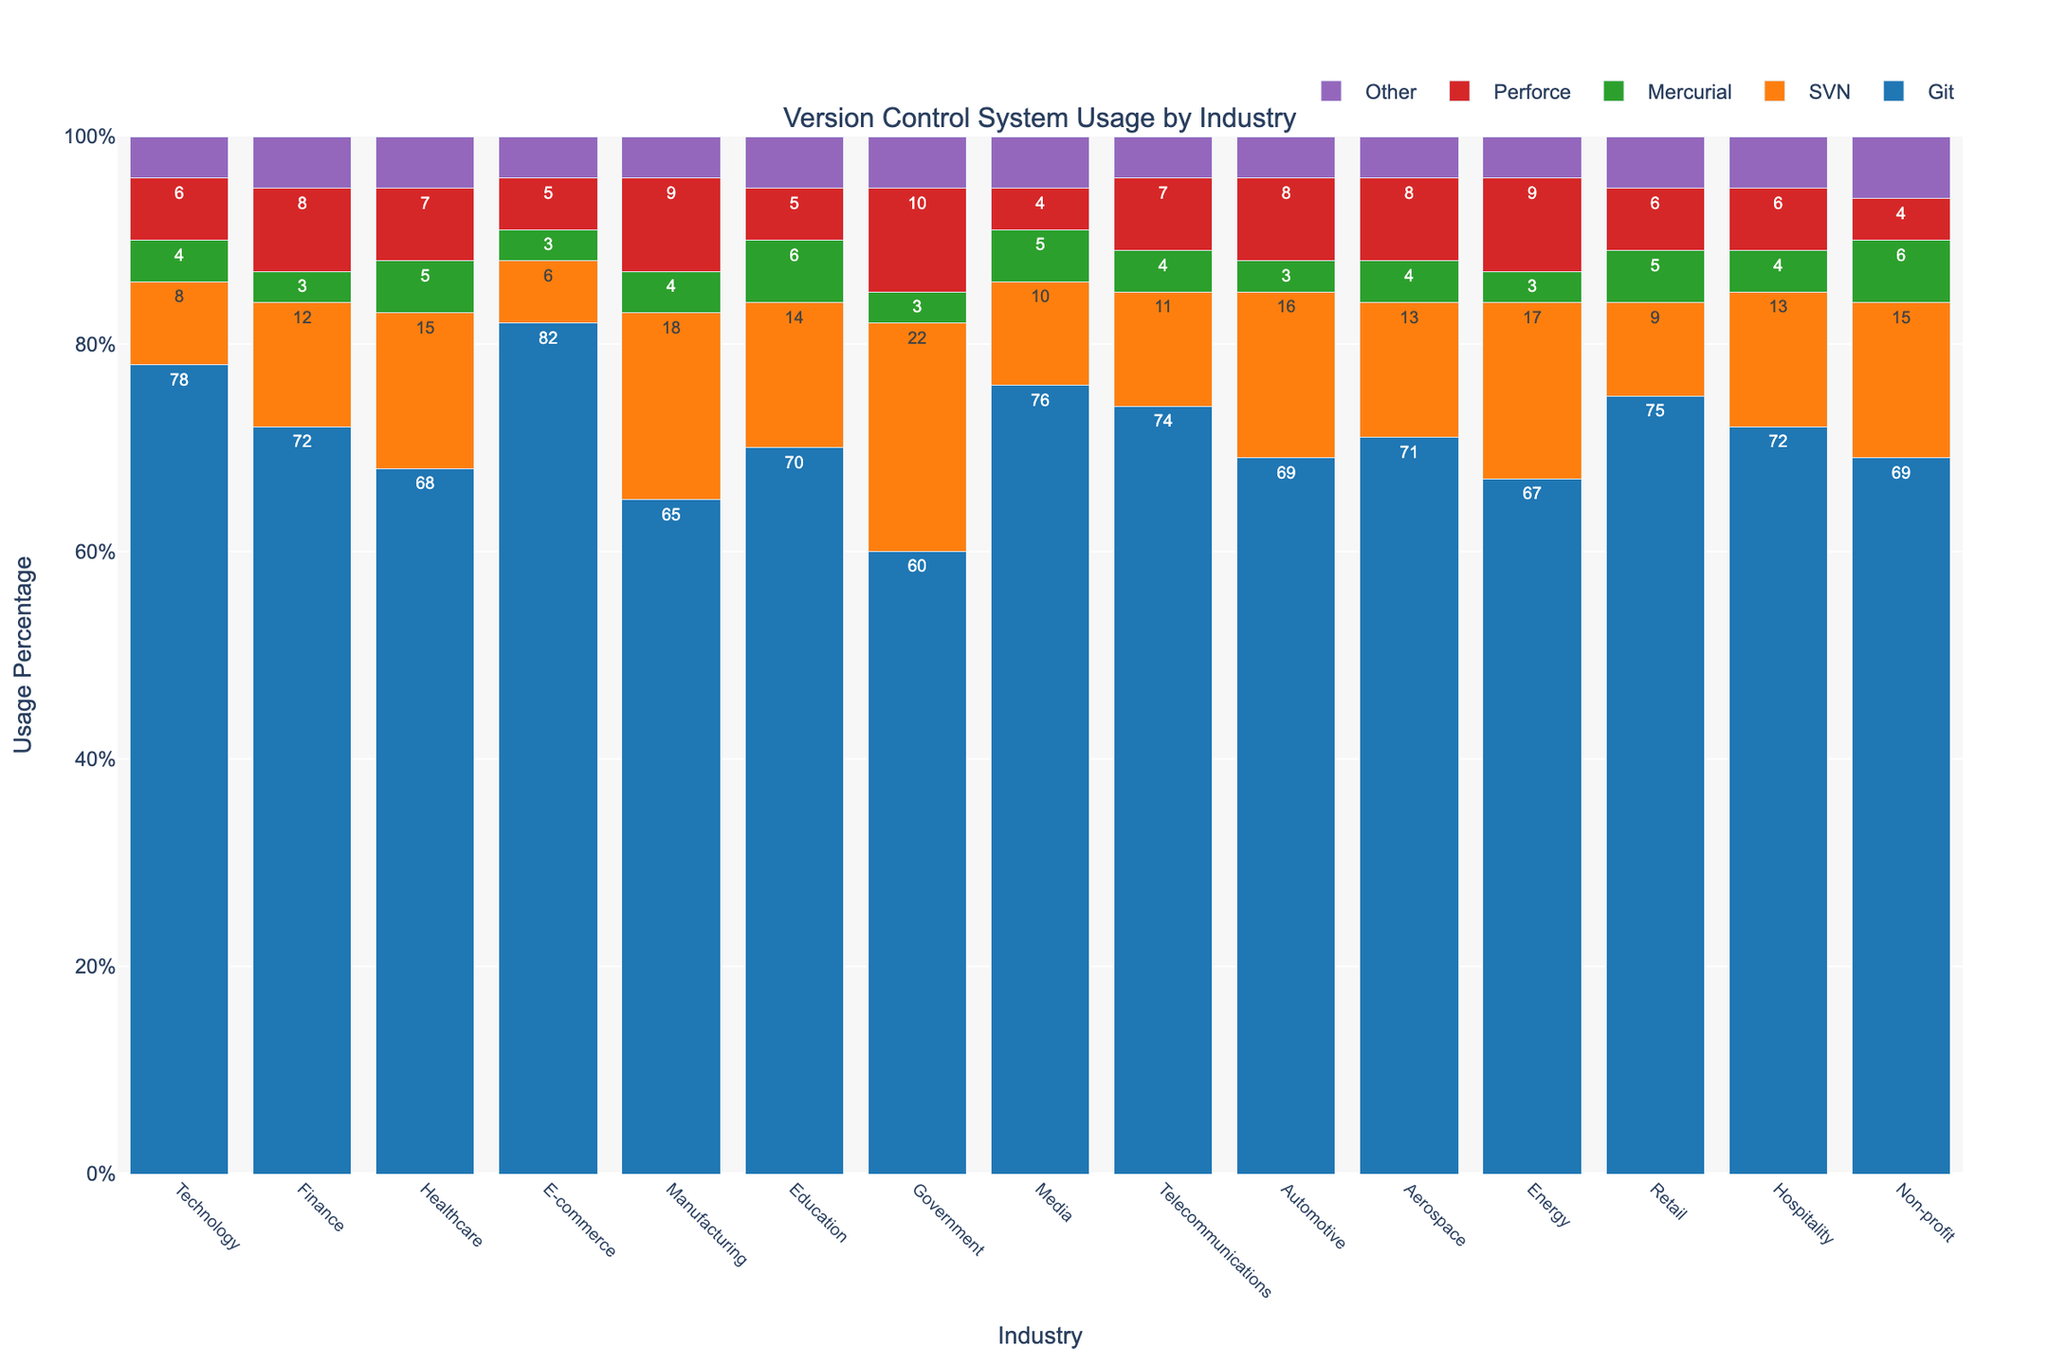What is the most popular version control system across all industries? By inspecting the heights of the bars representing Git across all industries, we can see that Git consistently has the highest percentage, making it the most popular version control system.
Answer: Git Which industry has the highest usage of Perforce? By comparing the heights of the Perforce bars across all industries, it is noticeable that the Government industry has the highest usage at 10 percent.
Answer: Government How does SVN usage in the Manufacturing industry compare to that in the Technology industry? By comparing the heights of SVN bars for Manufacturing and Technology, it is evident that Manufacturing has a higher SVN usage at 18 percent versus 8 percent in Technology.
Answer: Manufacturing uses SVN more Which two industries have exactly equal percentages of Other version control systems? By checking the height of the Other bars, it is evident that multiple industries like Technology, E-commerce, Manufacturing, Telecommunications, Aerospace, Automotive, and Energy all have 4 percent usage, but two distinct industries with exactly the same should be highlighted. To be precise, Technology and E-commerce both have 4 percent usage of Other VCS.
Answer: Technology and E-commerce What is the sum of the usage percentages for Git and Mercurial in the Healthcare industry? In Healthcare, Git usage is 68 percent and Mercurial usage is 5 percent. Adding these together gives 68 + 5 = 73 percent.
Answer: 73 percent Which industry shows the least usage of Mercurial? By checking the heights of Mercurial bars across all industries, the Finance, E-commerce, Automotive, Telecommunications, Aerospace, and Energy industries all have the lowest, at 3 percent.
Answer: Finance, E-commerce, Automotive, Telecommunications, Aerospace, Energy What is the difference in usage percentage between Git and SVN in the Media industry? The usage of Git in Media is 76 percent and SVN is 10 percent. The difference is 76 - 10 = 66 percent.
Answer: 66 percent What is the average usage percentage of Git across all industries? Summing up the Git usage values across all industries gives 78 + 72 + 68 + 82 + 65 + 70 + 60 + 76 + 74 + 69 + 71 + 67 + 75 + 72 + 69 = 1068 percent. There are 15 industries, so the average is 1068 / 15 = 71.2 percent.
Answer: 71.2 percent How does the usage percentage of Git in the Government sector compare to the Retail sector? Git usage in the Government sector is 60 percent, while in the Retail sector, it is 75 percent. Thus, Git is used more in the Retail sector.
Answer: Git is used more in Retail What is the combined usage percentage of Mercurial and Other version control systems in the Non-profit sector? In Non-profit, Mercurial usage is 6 percent and Other usage is 6 percent too. Adding these together gives 6 + 6 = 12 percent.
Answer: 12 percent 